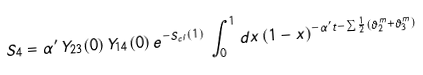<formula> <loc_0><loc_0><loc_500><loc_500>S _ { 4 } = \alpha ^ { \prime } \, Y _ { 2 3 } ( 0 ) \, Y _ { 1 4 } ( 0 ) \, e ^ { - S _ { c l } ( 1 ) } \, \int _ { 0 } ^ { 1 } d x \, ( 1 - x ) ^ { - \alpha ^ { \prime } t - \sum \frac { 1 } { 2 } ( \vartheta _ { 2 } ^ { m } + \vartheta _ { 3 } ^ { m } ) }</formula> 